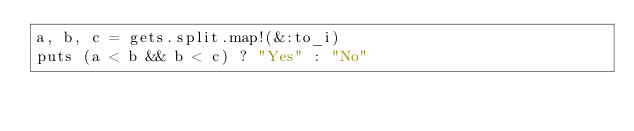<code> <loc_0><loc_0><loc_500><loc_500><_Ruby_>a, b, c = gets.split.map!(&:to_i)
puts (a < b && b < c) ? "Yes" : "No"

</code> 